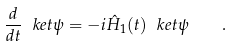Convert formula to latex. <formula><loc_0><loc_0><loc_500><loc_500>\frac { d } { d t } \ k e t \psi = - i \hat { H } _ { 1 } ( t ) \ k e t \psi \quad .</formula> 